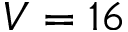<formula> <loc_0><loc_0><loc_500><loc_500>V = 1 6</formula> 